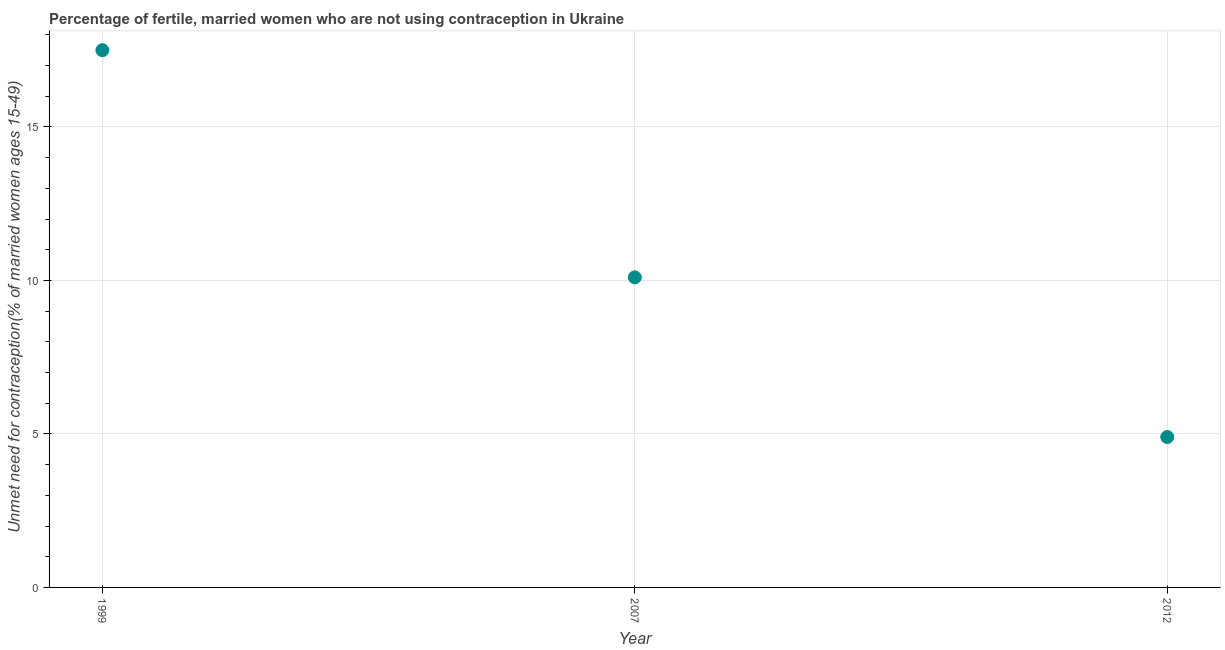In which year was the number of married women who are not using contraception maximum?
Make the answer very short. 1999. What is the sum of the number of married women who are not using contraception?
Your answer should be very brief. 32.5. What is the difference between the number of married women who are not using contraception in 2007 and 2012?
Your answer should be compact. 5.2. What is the average number of married women who are not using contraception per year?
Ensure brevity in your answer.  10.83. What is the median number of married women who are not using contraception?
Offer a very short reply. 10.1. Do a majority of the years between 2012 and 1999 (inclusive) have number of married women who are not using contraception greater than 2 %?
Ensure brevity in your answer.  No. What is the ratio of the number of married women who are not using contraception in 2007 to that in 2012?
Make the answer very short. 2.06. Is the difference between the number of married women who are not using contraception in 1999 and 2007 greater than the difference between any two years?
Offer a very short reply. No. What is the difference between the highest and the second highest number of married women who are not using contraception?
Give a very brief answer. 7.4. Is the sum of the number of married women who are not using contraception in 2007 and 2012 greater than the maximum number of married women who are not using contraception across all years?
Provide a short and direct response. No. What is the difference between the highest and the lowest number of married women who are not using contraception?
Offer a very short reply. 12.6. In how many years, is the number of married women who are not using contraception greater than the average number of married women who are not using contraception taken over all years?
Your answer should be very brief. 1. Does the number of married women who are not using contraception monotonically increase over the years?
Provide a succinct answer. No. What is the difference between two consecutive major ticks on the Y-axis?
Your response must be concise. 5. Does the graph contain grids?
Your answer should be compact. Yes. What is the title of the graph?
Your answer should be compact. Percentage of fertile, married women who are not using contraception in Ukraine. What is the label or title of the Y-axis?
Give a very brief answer.  Unmet need for contraception(% of married women ages 15-49). What is the  Unmet need for contraception(% of married women ages 15-49) in 2012?
Provide a short and direct response. 4.9. What is the difference between the  Unmet need for contraception(% of married women ages 15-49) in 1999 and 2007?
Your answer should be compact. 7.4. What is the difference between the  Unmet need for contraception(% of married women ages 15-49) in 1999 and 2012?
Your answer should be compact. 12.6. What is the difference between the  Unmet need for contraception(% of married women ages 15-49) in 2007 and 2012?
Provide a succinct answer. 5.2. What is the ratio of the  Unmet need for contraception(% of married women ages 15-49) in 1999 to that in 2007?
Your answer should be compact. 1.73. What is the ratio of the  Unmet need for contraception(% of married women ages 15-49) in 1999 to that in 2012?
Make the answer very short. 3.57. What is the ratio of the  Unmet need for contraception(% of married women ages 15-49) in 2007 to that in 2012?
Offer a very short reply. 2.06. 